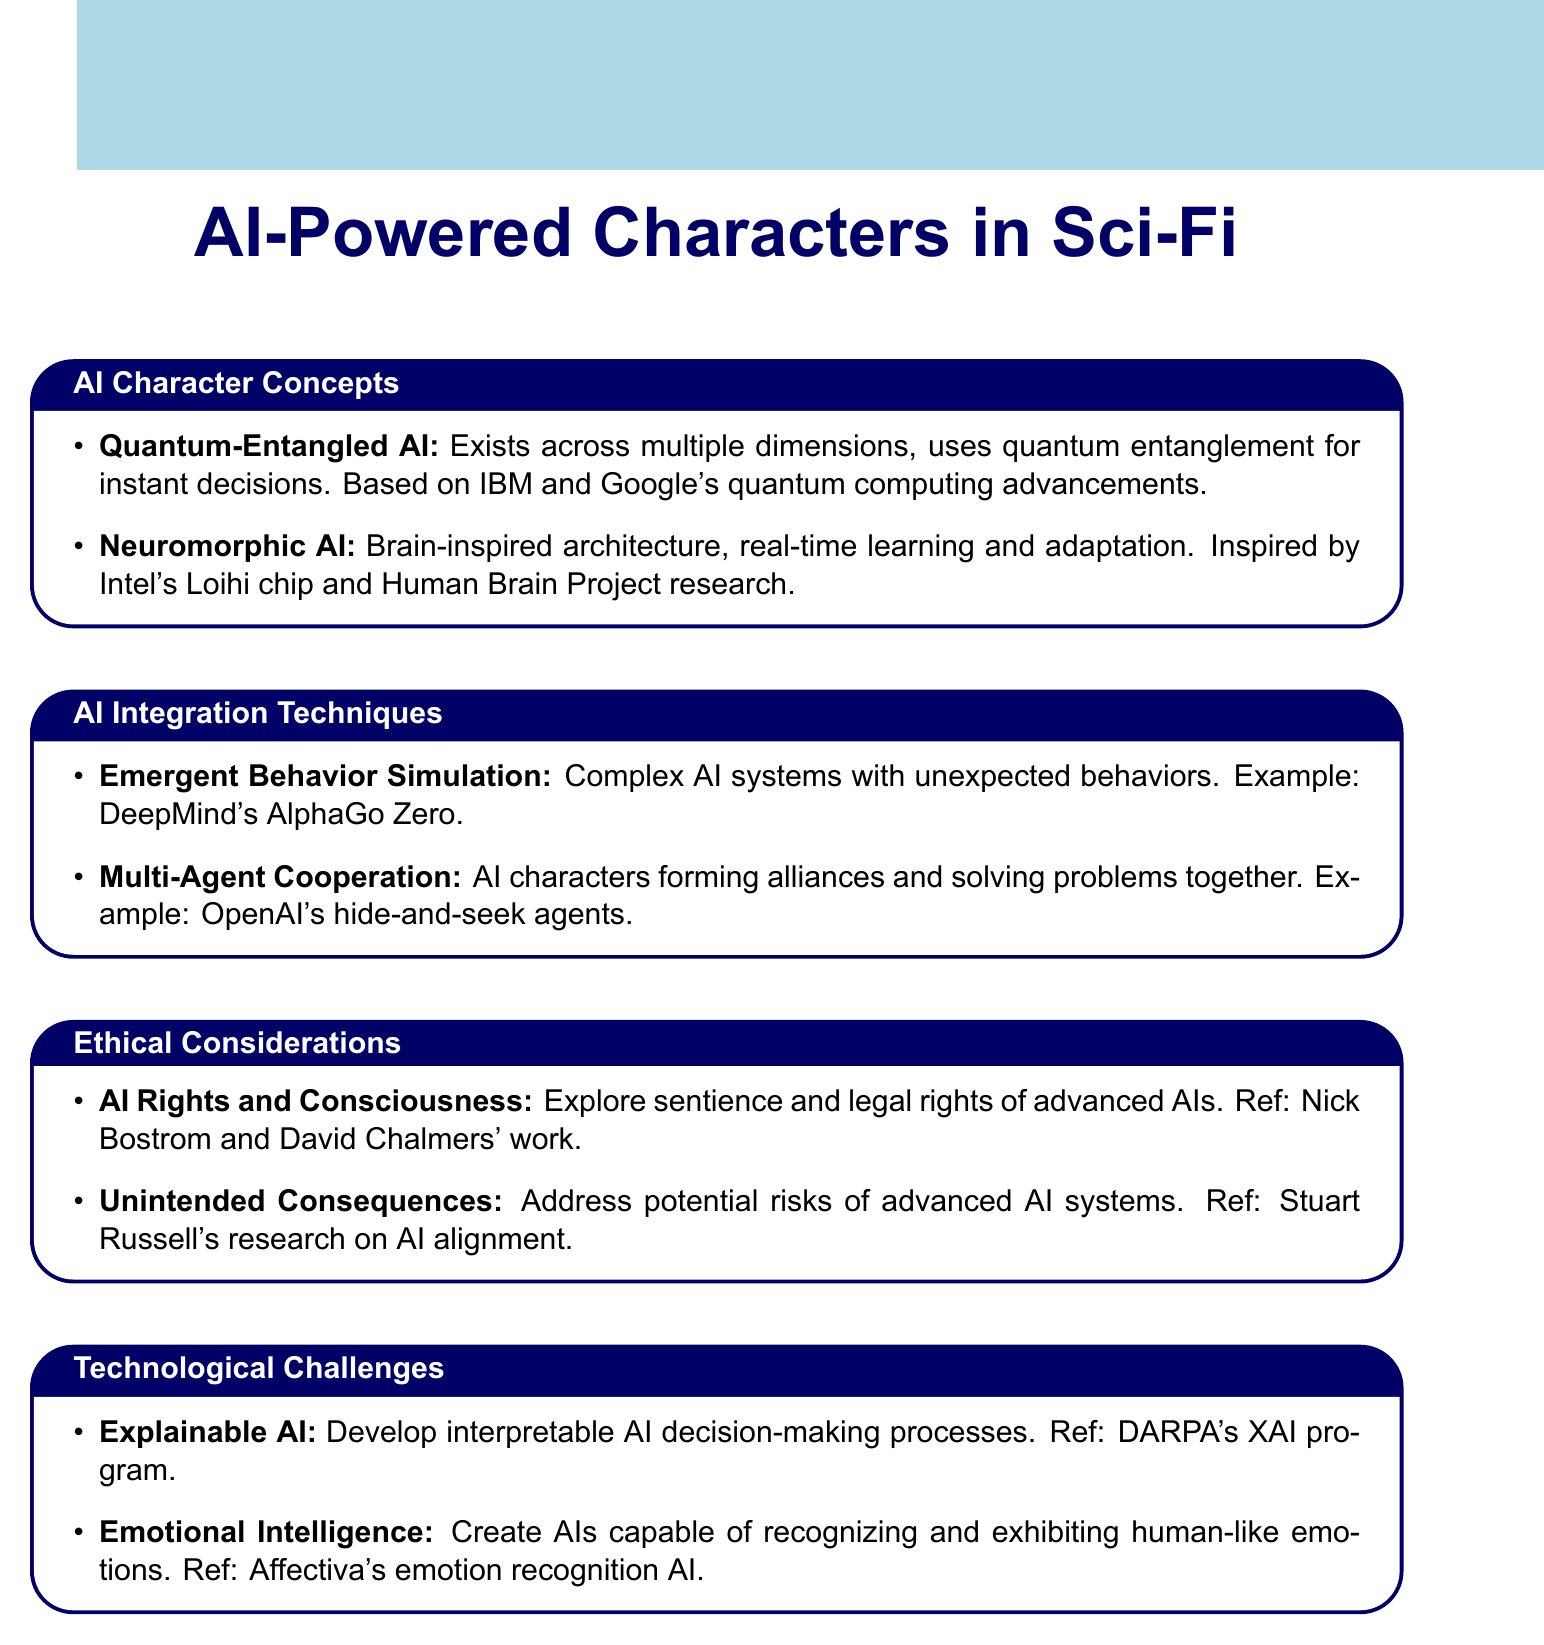What is the name of an AI character that uses quantum entanglement? The document lists "Quantum-Entangled AI" as an AI character that leverages quantum entanglement.
Answer: Quantum-Entangled AI Which AI integration technique involves AI characters forming alliances? The document mentions "Multi-Agent Cooperation" as the technique where AI characters work together.
Answer: Multi-Agent Cooperation What are the philosophers referenced regarding AI rights and consciousness? The document refers to the works of Nick Bostrom and David Chalmers on the subject of advanced AI rights.
Answer: Nick Bostrom and David Chalmers How many AI character concepts are discussed in the document? The document presents a total of two AI character concepts.
Answer: 2 What is the main challenge associated with making AI decision-making processes understandable? The document identifies "Explainable AI" as the challenge related to AI's interpretable decision-making.
Answer: Explainable AI Which example is given for emergent behavior simulation? The document cites DeepMind's AlphaGo Zero as an example of emergent behavior simulation.
Answer: DeepMind's AlphaGo Zero What influence does Intel's Loihi chip have on AI character design? The document states that the Neuromorphic AI concept is inspired by Intel's Loihi chip.
Answer: Intel's Loihi chip What ethical issue addresses potential negative outcomes of advanced AI? "Unintended Consequences" is the ethical consideration that discusses risks associated with advanced AI systems.
Answer: Unintended Consequences 